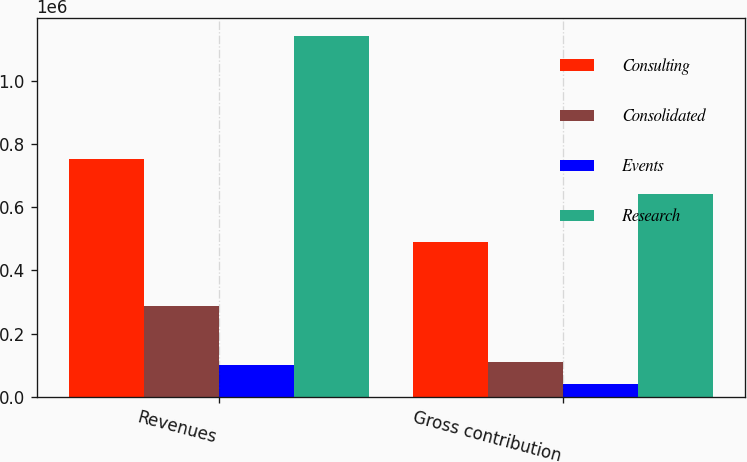Convert chart. <chart><loc_0><loc_0><loc_500><loc_500><stacked_bar_chart><ecel><fcel>Revenues<fcel>Gross contribution<nl><fcel>Consulting<fcel>752505<fcel>489862<nl><fcel>Consolidated<fcel>286847<fcel>112099<nl><fcel>Events<fcel>100448<fcel>40945<nl><fcel>Research<fcel>1.1398e+06<fcel>642906<nl></chart> 